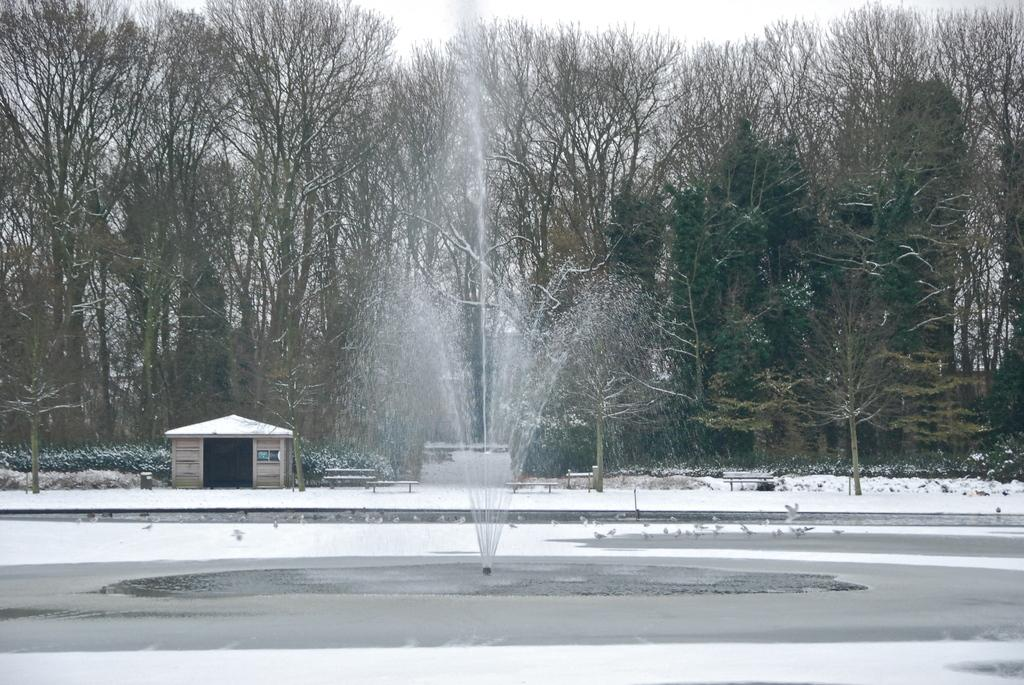What type of vegetation can be seen in the image? There are trees in the image. What type of structure is present in the image? There is a house in the image. What type of water feature is in the image? There is a fountain in the image. What type of seating is available in the image? There are benches in the image. What weather condition is depicted in the image? There is snow visible in the image. Can you see any chickens playing on the swing in the image? There are no chickens or swings present in the image. Is there a fight happening between the trees in the image? There is no fight depicted in the image; it shows trees, a house, a fountain, benches, and snow. 